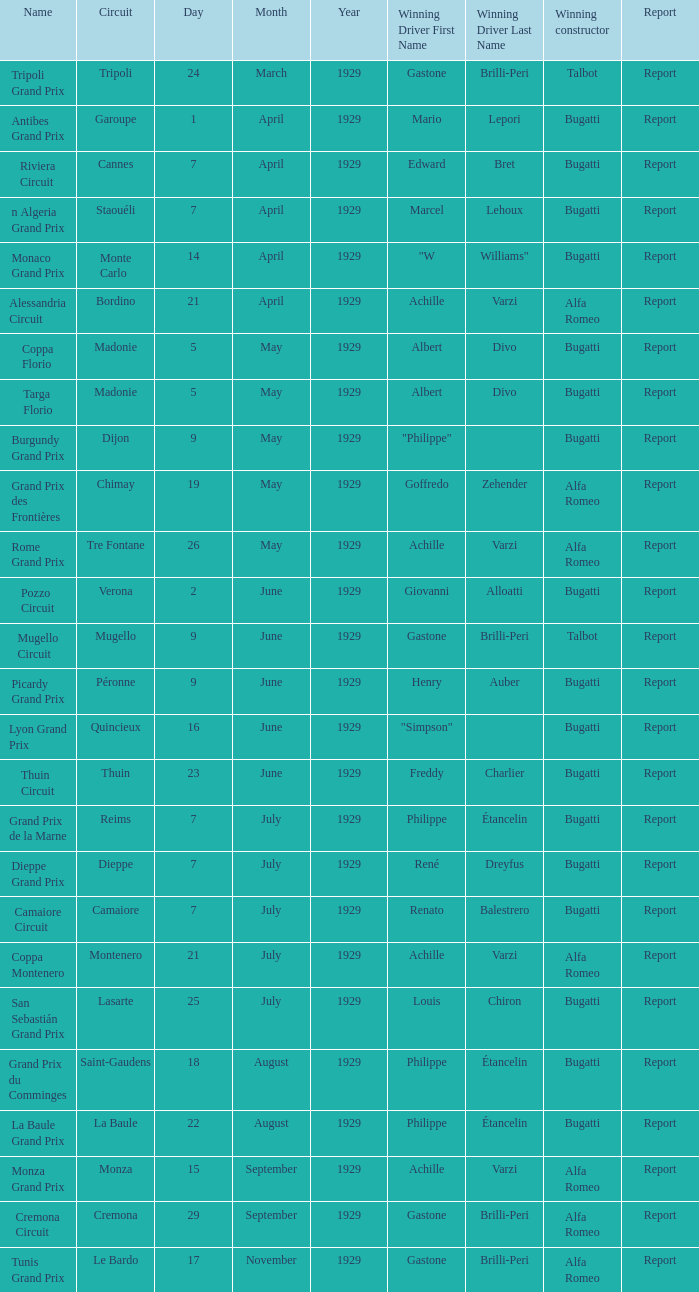What Circuit has a Date of 25 july? Lasarte. 